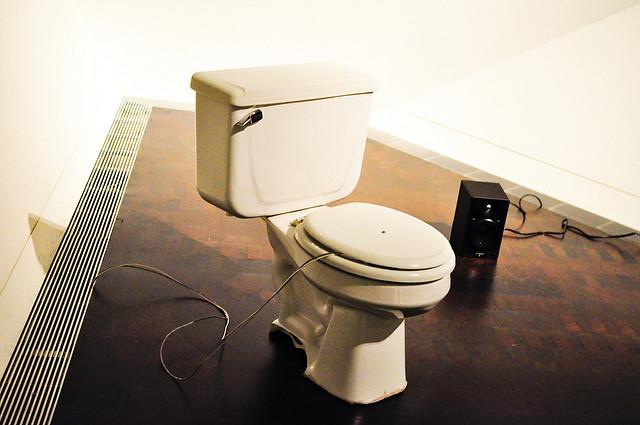Would you feel comfortable using this toilet?
Answer briefly. No. Is this an art exhibit?
Short answer required. Yes. Is the handle on the left or right side of the toilet tank?
Concise answer only. Left. 